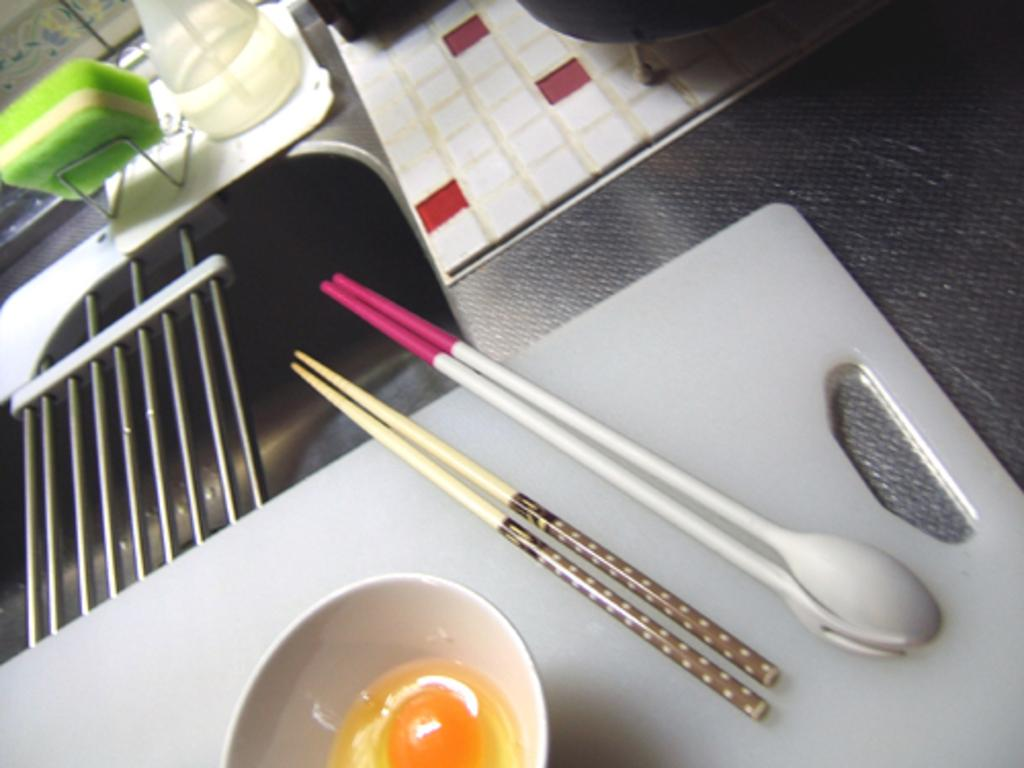What utensil can be seen in the image? There is a spoon in the image. What type of sticks are present in the image? There are wooden sticks in the image. What is the bowl used for in the image? The bowl is used to hold other objects in the image. Can you describe any other objects present in the image? There are other objects present in the image, but their specific details are not mentioned in the provided facts. What type of government is depicted in the image? There is no reference to a government in the image, so it is not possible to answer that question. 